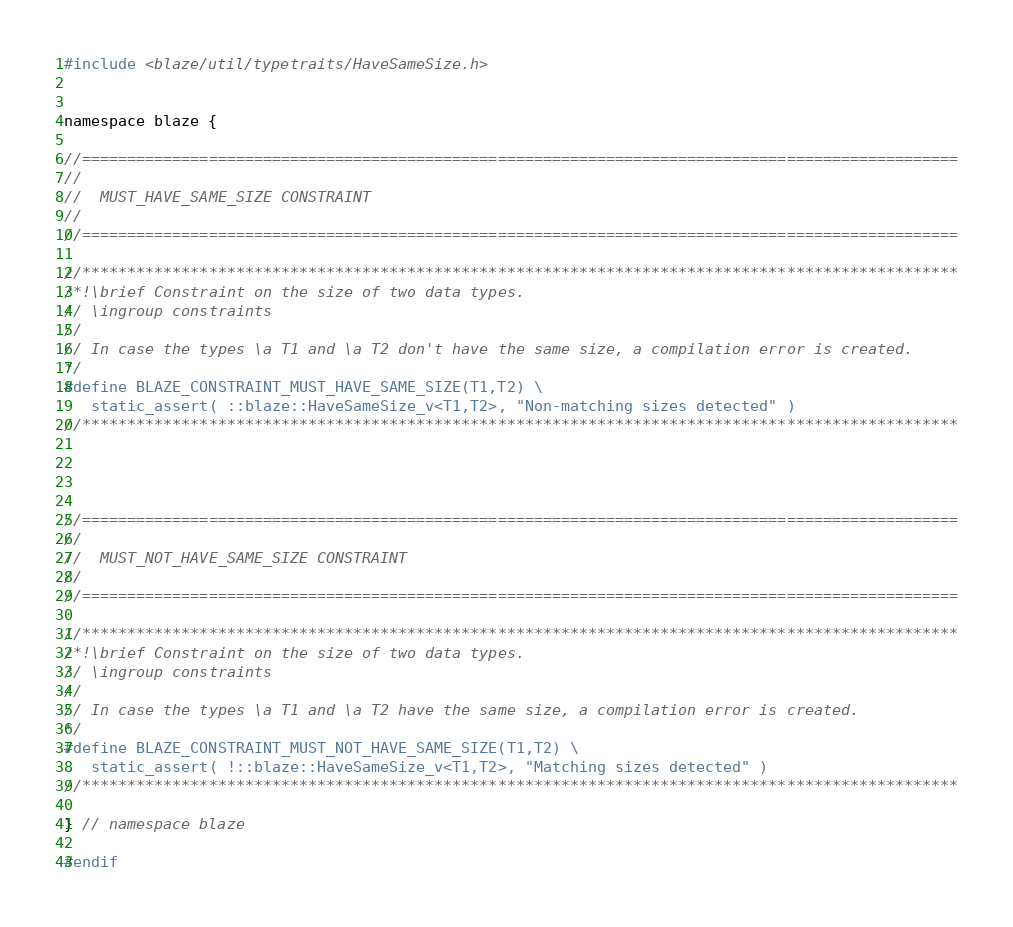Convert code to text. <code><loc_0><loc_0><loc_500><loc_500><_C_>
#include <blaze/util/typetraits/HaveSameSize.h>


namespace blaze {

//=================================================================================================
//
//  MUST_HAVE_SAME_SIZE CONSTRAINT
//
//=================================================================================================

//*************************************************************************************************
/*!\brief Constraint on the size of two data types.
// \ingroup constraints
//
// In case the types \a T1 and \a T2 don't have the same size, a compilation error is created.
*/
#define BLAZE_CONSTRAINT_MUST_HAVE_SAME_SIZE(T1,T2) \
   static_assert( ::blaze::HaveSameSize_v<T1,T2>, "Non-matching sizes detected" )
//*************************************************************************************************




//=================================================================================================
//
//  MUST_NOT_HAVE_SAME_SIZE CONSTRAINT
//
//=================================================================================================

//*************************************************************************************************
/*!\brief Constraint on the size of two data types.
// \ingroup constraints
//
// In case the types \a T1 and \a T2 have the same size, a compilation error is created.
*/
#define BLAZE_CONSTRAINT_MUST_NOT_HAVE_SAME_SIZE(T1,T2) \
   static_assert( !::blaze::HaveSameSize_v<T1,T2>, "Matching sizes detected" )
//*************************************************************************************************

} // namespace blaze

#endif
</code> 